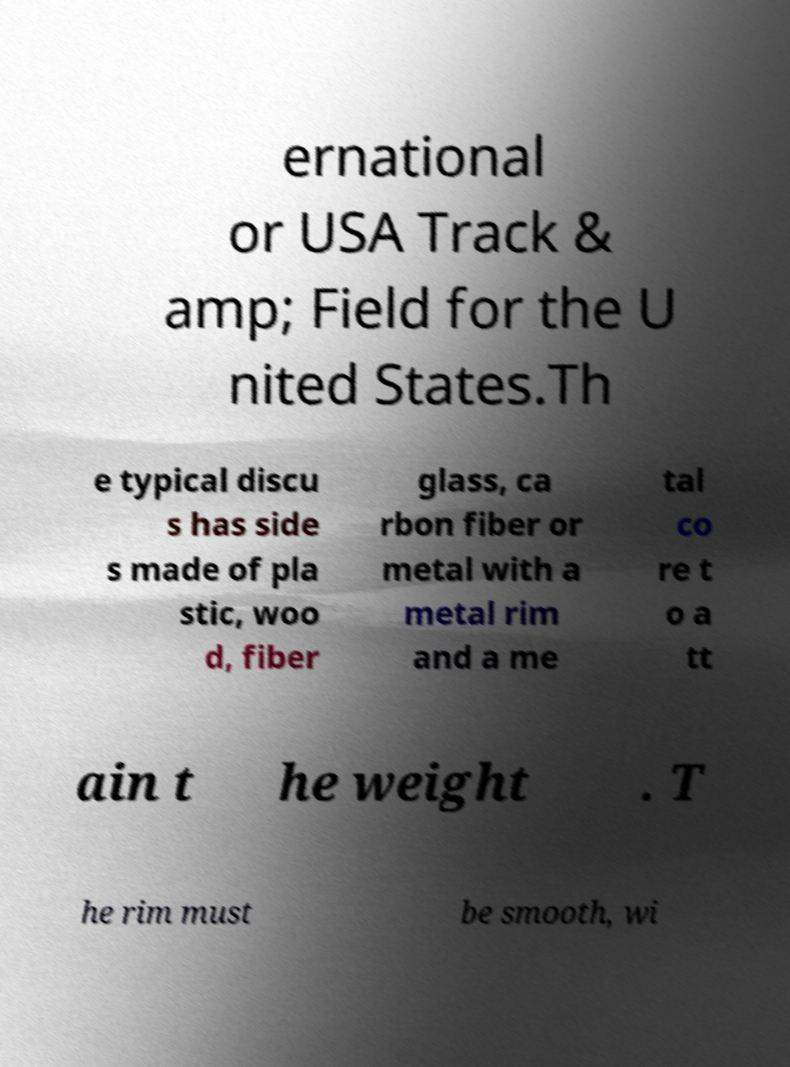Please identify and transcribe the text found in this image. ernational or USA Track & amp; Field for the U nited States.Th e typical discu s has side s made of pla stic, woo d, fiber glass, ca rbon fiber or metal with a metal rim and a me tal co re t o a tt ain t he weight . T he rim must be smooth, wi 